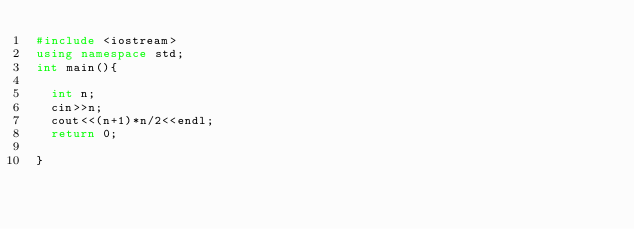<code> <loc_0><loc_0><loc_500><loc_500><_C++_>#include <iostream>
using namespace	std;
int main(){

  int n;
  cin>>n;
  cout<<(n+1)*n/2<<endl;
  return 0;

}

</code> 